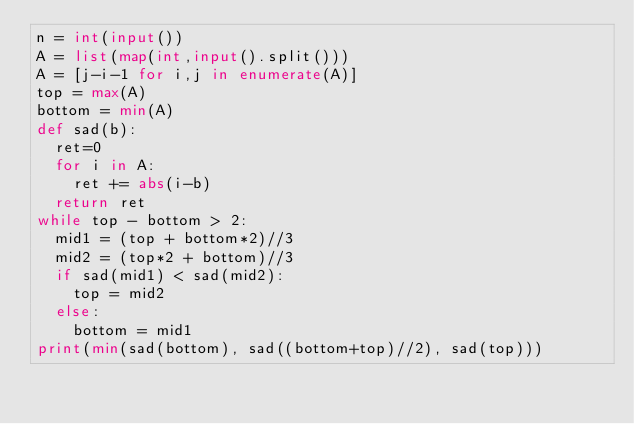<code> <loc_0><loc_0><loc_500><loc_500><_Python_>n = int(input())
A = list(map(int,input().split()))
A = [j-i-1 for i,j in enumerate(A)]
top = max(A)
bottom = min(A)
def sad(b):
  ret=0
  for i in A:
    ret += abs(i-b)
  return ret
while top - bottom > 2:
  mid1 = (top + bottom*2)//3
  mid2 = (top*2 + bottom)//3
  if sad(mid1) < sad(mid2):
    top = mid2
  else:
    bottom = mid1
print(min(sad(bottom), sad((bottom+top)//2), sad(top)))
</code> 